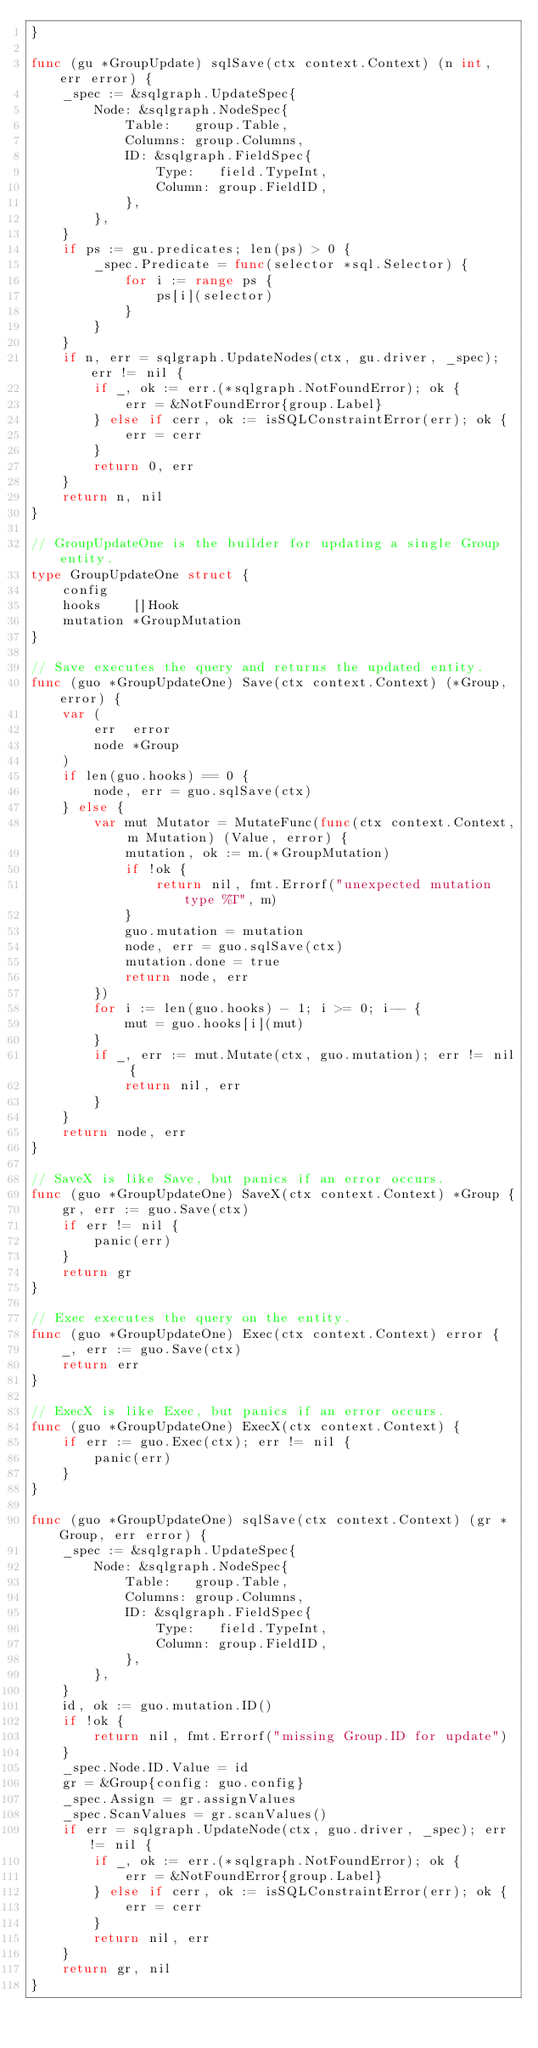Convert code to text. <code><loc_0><loc_0><loc_500><loc_500><_Go_>}

func (gu *GroupUpdate) sqlSave(ctx context.Context) (n int, err error) {
	_spec := &sqlgraph.UpdateSpec{
		Node: &sqlgraph.NodeSpec{
			Table:   group.Table,
			Columns: group.Columns,
			ID: &sqlgraph.FieldSpec{
				Type:   field.TypeInt,
				Column: group.FieldID,
			},
		},
	}
	if ps := gu.predicates; len(ps) > 0 {
		_spec.Predicate = func(selector *sql.Selector) {
			for i := range ps {
				ps[i](selector)
			}
		}
	}
	if n, err = sqlgraph.UpdateNodes(ctx, gu.driver, _spec); err != nil {
		if _, ok := err.(*sqlgraph.NotFoundError); ok {
			err = &NotFoundError{group.Label}
		} else if cerr, ok := isSQLConstraintError(err); ok {
			err = cerr
		}
		return 0, err
	}
	return n, nil
}

// GroupUpdateOne is the builder for updating a single Group entity.
type GroupUpdateOne struct {
	config
	hooks    []Hook
	mutation *GroupMutation
}

// Save executes the query and returns the updated entity.
func (guo *GroupUpdateOne) Save(ctx context.Context) (*Group, error) {
	var (
		err  error
		node *Group
	)
	if len(guo.hooks) == 0 {
		node, err = guo.sqlSave(ctx)
	} else {
		var mut Mutator = MutateFunc(func(ctx context.Context, m Mutation) (Value, error) {
			mutation, ok := m.(*GroupMutation)
			if !ok {
				return nil, fmt.Errorf("unexpected mutation type %T", m)
			}
			guo.mutation = mutation
			node, err = guo.sqlSave(ctx)
			mutation.done = true
			return node, err
		})
		for i := len(guo.hooks) - 1; i >= 0; i-- {
			mut = guo.hooks[i](mut)
		}
		if _, err := mut.Mutate(ctx, guo.mutation); err != nil {
			return nil, err
		}
	}
	return node, err
}

// SaveX is like Save, but panics if an error occurs.
func (guo *GroupUpdateOne) SaveX(ctx context.Context) *Group {
	gr, err := guo.Save(ctx)
	if err != nil {
		panic(err)
	}
	return gr
}

// Exec executes the query on the entity.
func (guo *GroupUpdateOne) Exec(ctx context.Context) error {
	_, err := guo.Save(ctx)
	return err
}

// ExecX is like Exec, but panics if an error occurs.
func (guo *GroupUpdateOne) ExecX(ctx context.Context) {
	if err := guo.Exec(ctx); err != nil {
		panic(err)
	}
}

func (guo *GroupUpdateOne) sqlSave(ctx context.Context) (gr *Group, err error) {
	_spec := &sqlgraph.UpdateSpec{
		Node: &sqlgraph.NodeSpec{
			Table:   group.Table,
			Columns: group.Columns,
			ID: &sqlgraph.FieldSpec{
				Type:   field.TypeInt,
				Column: group.FieldID,
			},
		},
	}
	id, ok := guo.mutation.ID()
	if !ok {
		return nil, fmt.Errorf("missing Group.ID for update")
	}
	_spec.Node.ID.Value = id
	gr = &Group{config: guo.config}
	_spec.Assign = gr.assignValues
	_spec.ScanValues = gr.scanValues()
	if err = sqlgraph.UpdateNode(ctx, guo.driver, _spec); err != nil {
		if _, ok := err.(*sqlgraph.NotFoundError); ok {
			err = &NotFoundError{group.Label}
		} else if cerr, ok := isSQLConstraintError(err); ok {
			err = cerr
		}
		return nil, err
	}
	return gr, nil
}
</code> 